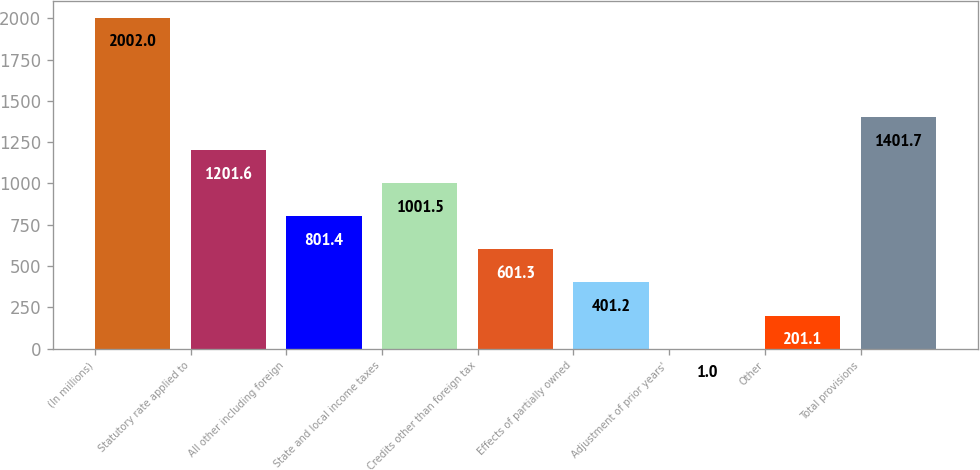<chart> <loc_0><loc_0><loc_500><loc_500><bar_chart><fcel>(In millions)<fcel>Statutory rate applied to<fcel>All other including foreign<fcel>State and local income taxes<fcel>Credits other than foreign tax<fcel>Effects of partially owned<fcel>Adjustment of prior years'<fcel>Other<fcel>Total provisions<nl><fcel>2002<fcel>1201.6<fcel>801.4<fcel>1001.5<fcel>601.3<fcel>401.2<fcel>1<fcel>201.1<fcel>1401.7<nl></chart> 